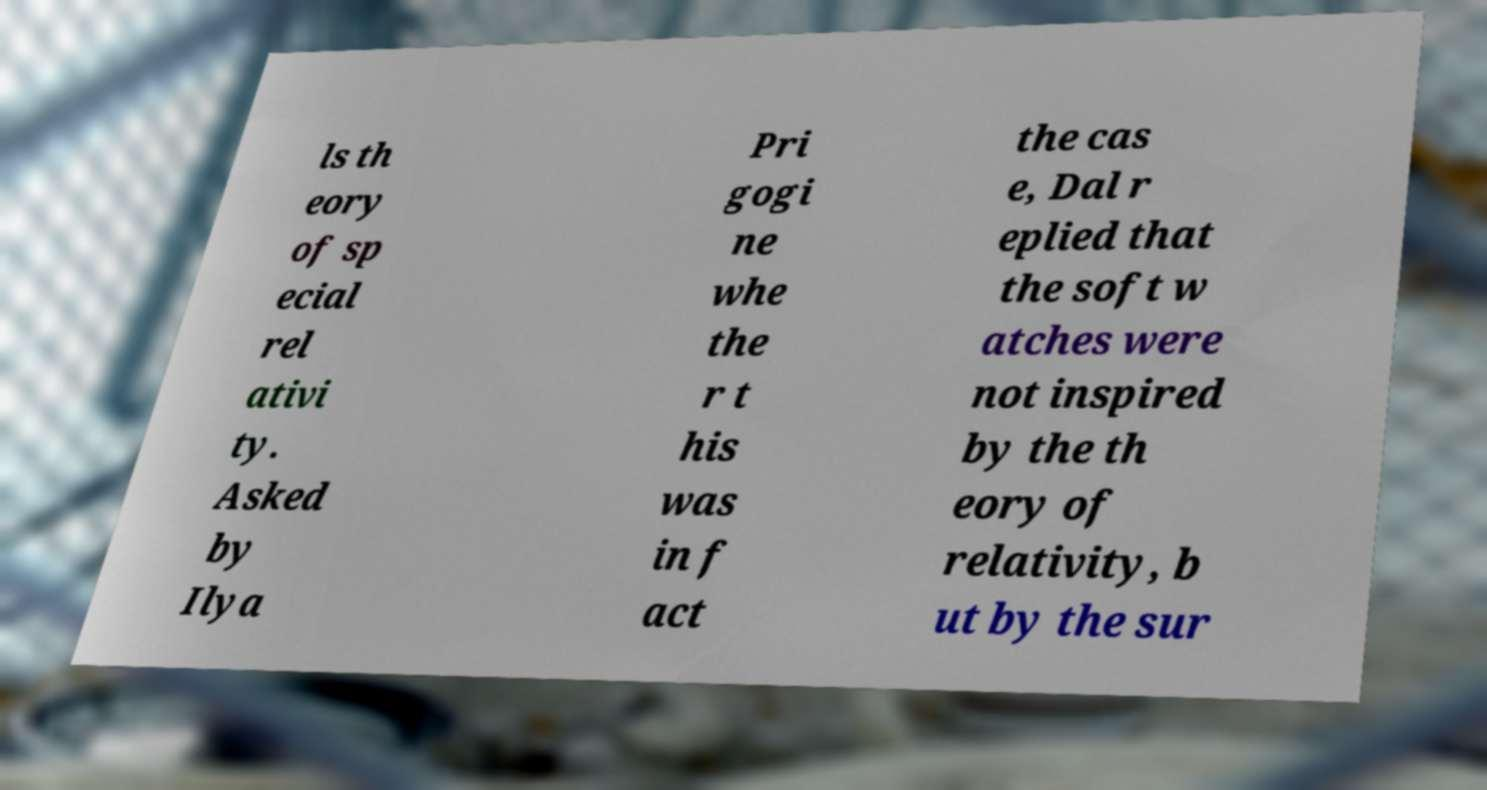Could you extract and type out the text from this image? ls th eory of sp ecial rel ativi ty. Asked by Ilya Pri gogi ne whe the r t his was in f act the cas e, Dal r eplied that the soft w atches were not inspired by the th eory of relativity, b ut by the sur 